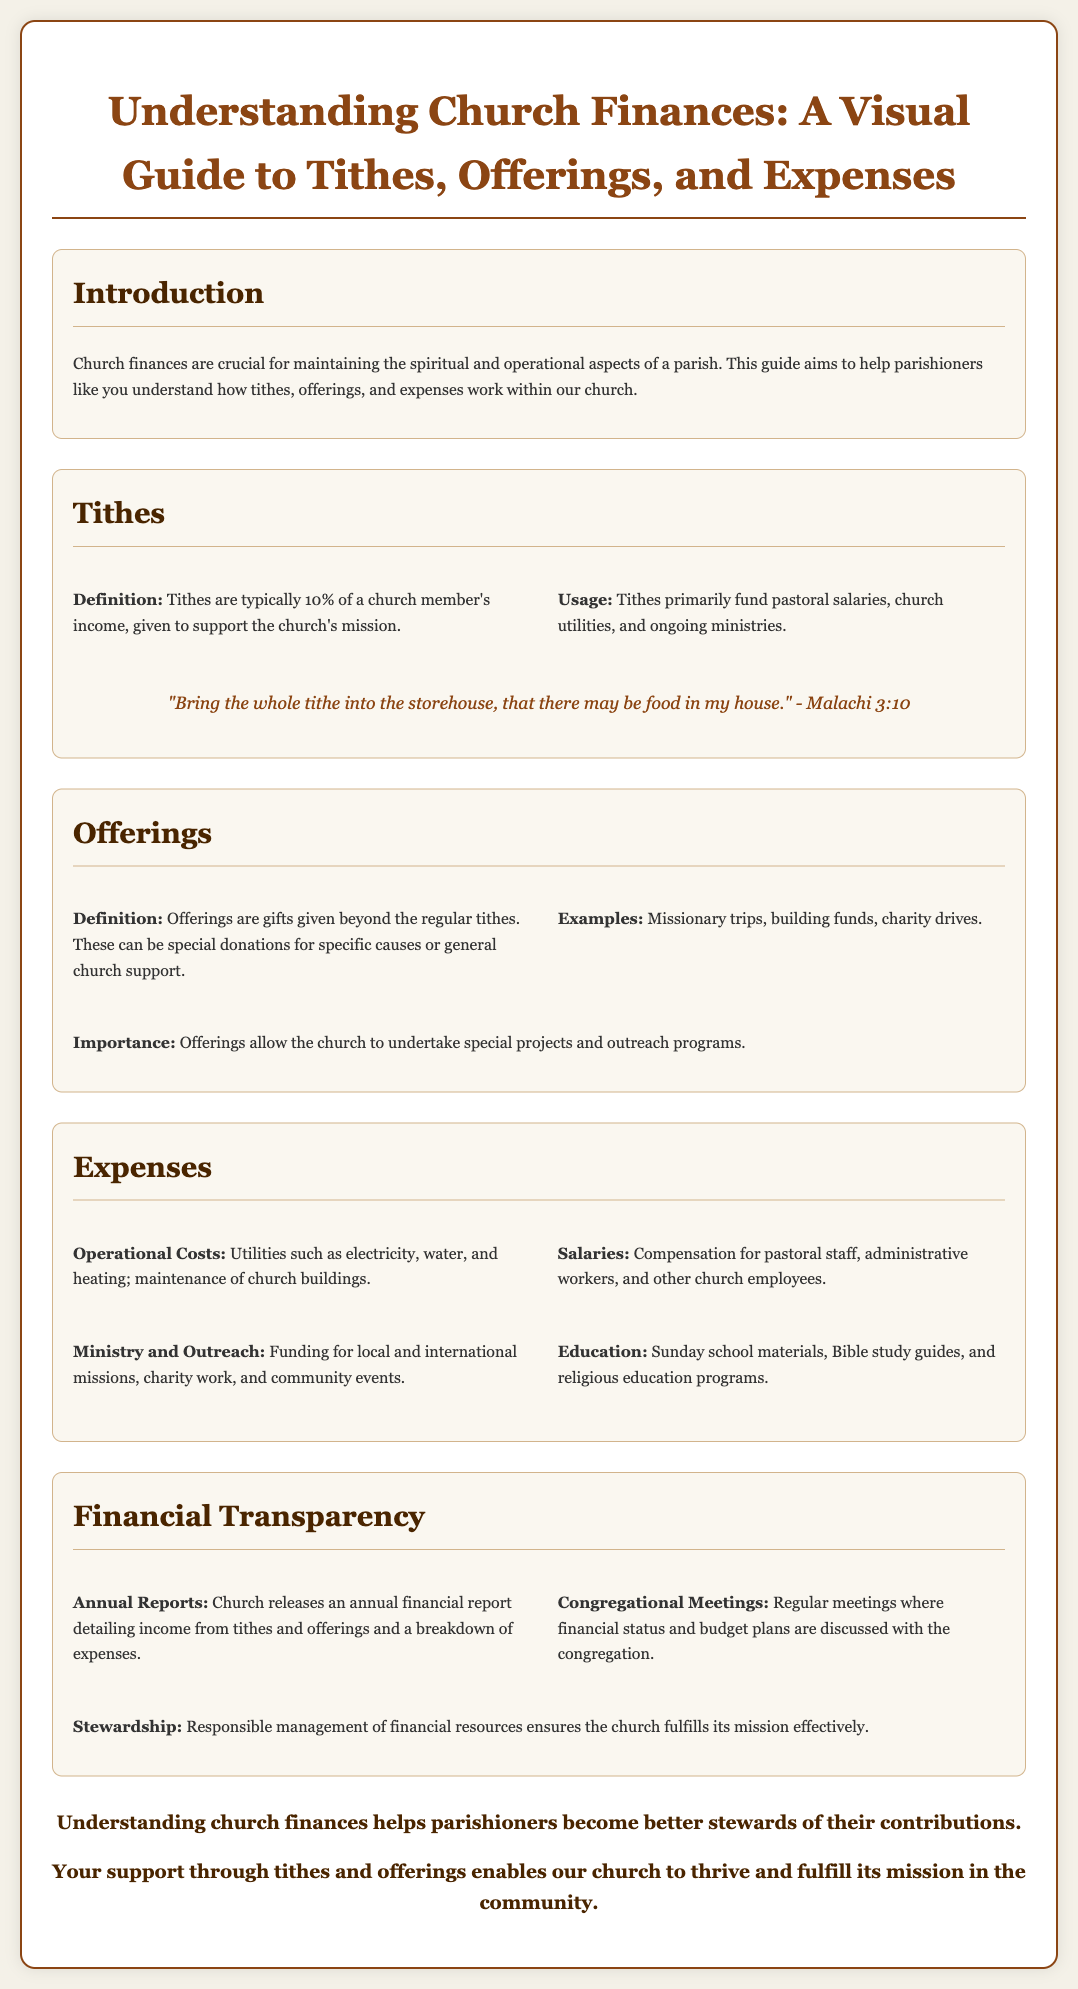What are tithes? Tithes are typically 10% of a church member's income, given to support the church's mission.
Answer: 10% of income What is the primary usage of tithes? Tithes primarily fund pastoral salaries, church utilities, and ongoing ministries.
Answer: Fund pastoral salaries, church utilities, and ongoing ministries What do offerings represent? Offerings are gifts given beyond the regular tithes.
Answer: Gifts beyond regular tithes Give an example of an offering. Examples include missionary trips, building funds, and charity drives.
Answer: Missionary trips What are operational costs mentioned in the document? Operational costs include utilities such as electricity, water, and heating; maintenance of church buildings.
Answer: Utilities and maintenance What does the church release annually? Church releases an annual financial report detailing income from tithes and offerings and a breakdown of expenses.
Answer: Annual financial report What is the purpose of congregational meetings? Regular meetings where financial status and budget plans are discussed with the congregation.
Answer: Discuss financial status and budget plans What is a key aspect of financial transparency? Responsible management of financial resources ensures the church fulfills its mission effectively.
Answer: Responsible management of financial resources What is highlighted in the conclusion? Understanding church finances helps parishioners become better stewards of their contributions.
Answer: Helps parishioners become better stewards 